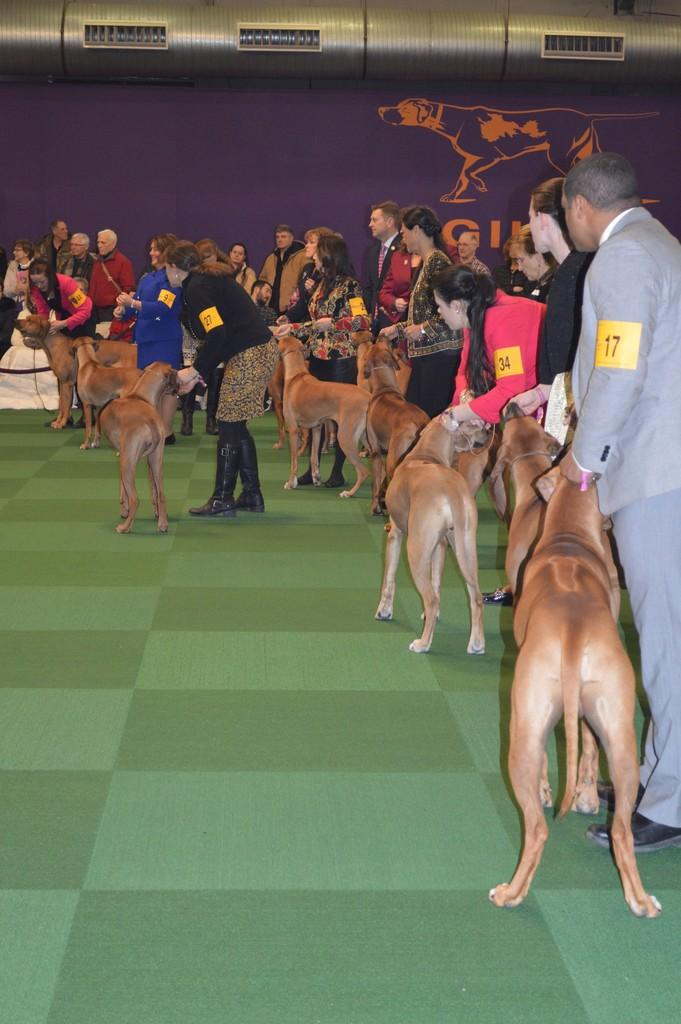What is the main subject of the image? The main subject of the image is a group of people. Where are the people located in the image? The people are standing on the floor in the image. What can be seen on the people in the image? The people have stickers on them. What other animals are present in the image besides the people? There are dogs in the image. How many rabbits can be seen in the image? There are no rabbits present in the image. What letters are written on the stickers on the people? The provided facts do not mention any specific letters on the stickers, so we cannot answer that question. 